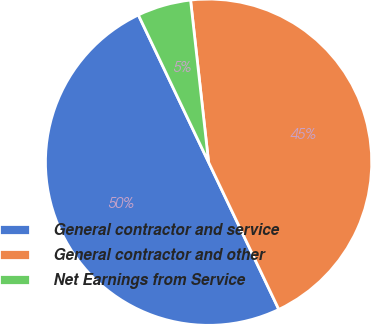Convert chart. <chart><loc_0><loc_0><loc_500><loc_500><pie_chart><fcel>General contractor and service<fcel>General contractor and other<fcel>Net Earnings from Service<nl><fcel>50.0%<fcel>44.68%<fcel>5.32%<nl></chart> 